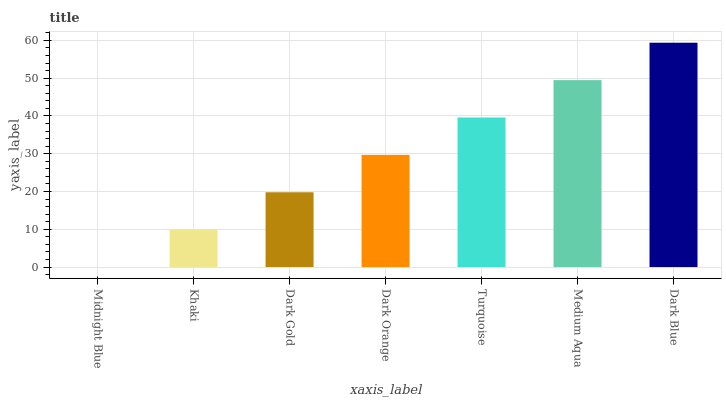Is Midnight Blue the minimum?
Answer yes or no. Yes. Is Dark Blue the maximum?
Answer yes or no. Yes. Is Khaki the minimum?
Answer yes or no. No. Is Khaki the maximum?
Answer yes or no. No. Is Khaki greater than Midnight Blue?
Answer yes or no. Yes. Is Midnight Blue less than Khaki?
Answer yes or no. Yes. Is Midnight Blue greater than Khaki?
Answer yes or no. No. Is Khaki less than Midnight Blue?
Answer yes or no. No. Is Dark Orange the high median?
Answer yes or no. Yes. Is Dark Orange the low median?
Answer yes or no. Yes. Is Turquoise the high median?
Answer yes or no. No. Is Dark Gold the low median?
Answer yes or no. No. 